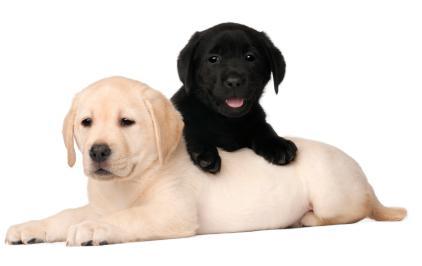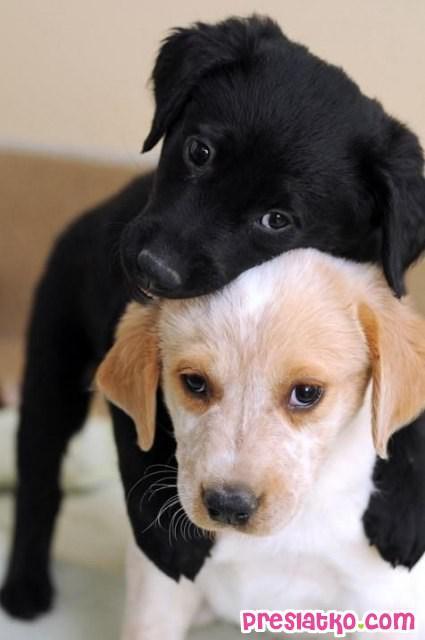The first image is the image on the left, the second image is the image on the right. Analyze the images presented: Is the assertion "Both images contain the same number of puppies." valid? Answer yes or no. Yes. 